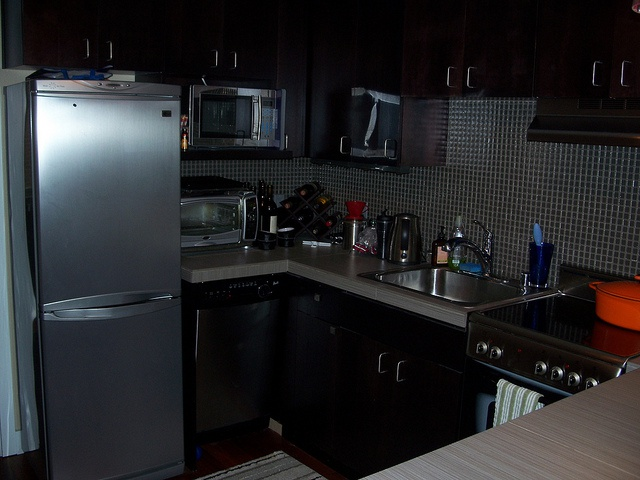Describe the objects in this image and their specific colors. I can see refrigerator in black, gray, darkblue, and white tones, oven in black and gray tones, oven in black, gray, maroon, and darkgray tones, microwave in black, gray, and blue tones, and sink in black, gray, and darkgray tones in this image. 